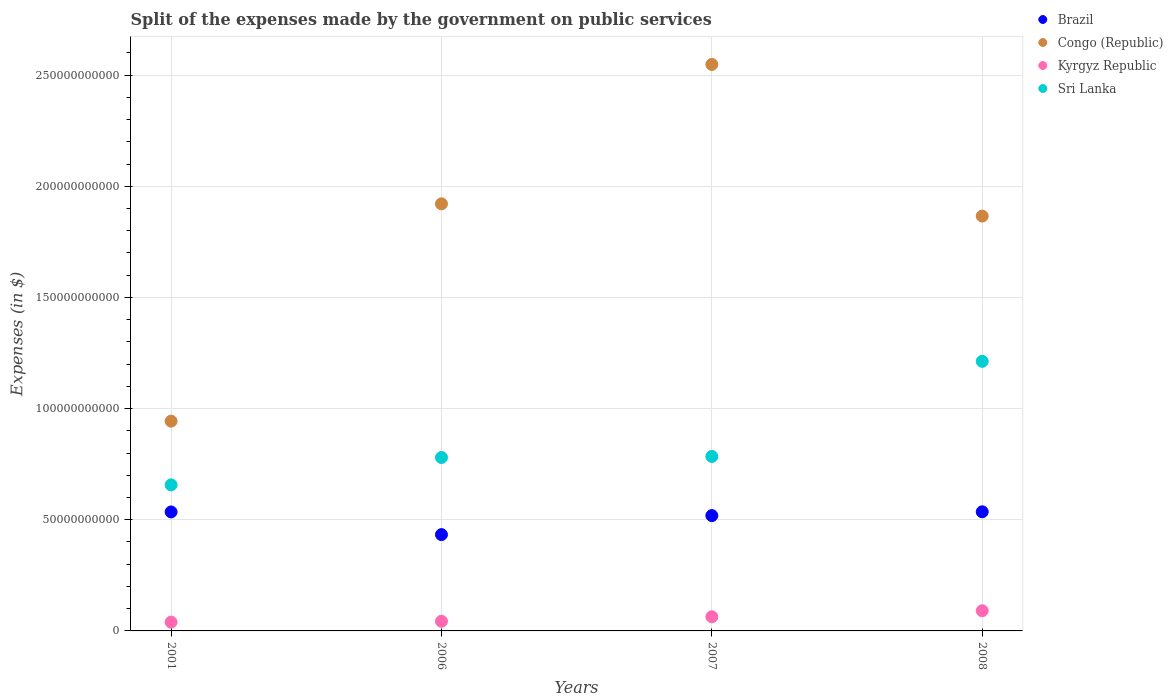How many different coloured dotlines are there?
Offer a very short reply. 4. Is the number of dotlines equal to the number of legend labels?
Your answer should be compact. Yes. What is the expenses made by the government on public services in Kyrgyz Republic in 2006?
Offer a terse response. 4.35e+09. Across all years, what is the maximum expenses made by the government on public services in Congo (Republic)?
Your response must be concise. 2.55e+11. Across all years, what is the minimum expenses made by the government on public services in Brazil?
Provide a short and direct response. 4.33e+1. In which year was the expenses made by the government on public services in Sri Lanka minimum?
Provide a short and direct response. 2001. What is the total expenses made by the government on public services in Brazil in the graph?
Your response must be concise. 2.02e+11. What is the difference between the expenses made by the government on public services in Sri Lanka in 2006 and that in 2007?
Ensure brevity in your answer.  -4.78e+08. What is the difference between the expenses made by the government on public services in Sri Lanka in 2006 and the expenses made by the government on public services in Brazil in 2008?
Keep it short and to the point. 2.44e+1. What is the average expenses made by the government on public services in Congo (Republic) per year?
Ensure brevity in your answer.  1.82e+11. In the year 2006, what is the difference between the expenses made by the government on public services in Congo (Republic) and expenses made by the government on public services in Brazil?
Offer a terse response. 1.49e+11. In how many years, is the expenses made by the government on public services in Sri Lanka greater than 150000000000 $?
Your answer should be compact. 0. What is the ratio of the expenses made by the government on public services in Congo (Republic) in 2001 to that in 2007?
Your answer should be very brief. 0.37. Is the expenses made by the government on public services in Sri Lanka in 2001 less than that in 2006?
Ensure brevity in your answer.  Yes. What is the difference between the highest and the second highest expenses made by the government on public services in Kyrgyz Republic?
Your response must be concise. 2.71e+09. What is the difference between the highest and the lowest expenses made by the government on public services in Kyrgyz Republic?
Provide a short and direct response. 5.13e+09. Is it the case that in every year, the sum of the expenses made by the government on public services in Congo (Republic) and expenses made by the government on public services in Brazil  is greater than the sum of expenses made by the government on public services in Sri Lanka and expenses made by the government on public services in Kyrgyz Republic?
Your answer should be very brief. Yes. Is it the case that in every year, the sum of the expenses made by the government on public services in Sri Lanka and expenses made by the government on public services in Kyrgyz Republic  is greater than the expenses made by the government on public services in Brazil?
Make the answer very short. Yes. Does the expenses made by the government on public services in Brazil monotonically increase over the years?
Provide a succinct answer. No. Is the expenses made by the government on public services in Sri Lanka strictly less than the expenses made by the government on public services in Congo (Republic) over the years?
Provide a short and direct response. Yes. How many dotlines are there?
Provide a short and direct response. 4. How many years are there in the graph?
Your response must be concise. 4. Are the values on the major ticks of Y-axis written in scientific E-notation?
Offer a very short reply. No. Does the graph contain any zero values?
Ensure brevity in your answer.  No. How many legend labels are there?
Give a very brief answer. 4. How are the legend labels stacked?
Give a very brief answer. Vertical. What is the title of the graph?
Make the answer very short. Split of the expenses made by the government on public services. What is the label or title of the X-axis?
Your answer should be very brief. Years. What is the label or title of the Y-axis?
Provide a succinct answer. Expenses (in $). What is the Expenses (in $) in Brazil in 2001?
Offer a very short reply. 5.35e+1. What is the Expenses (in $) of Congo (Republic) in 2001?
Provide a succinct answer. 9.43e+1. What is the Expenses (in $) in Kyrgyz Republic in 2001?
Your response must be concise. 3.95e+09. What is the Expenses (in $) in Sri Lanka in 2001?
Provide a succinct answer. 6.57e+1. What is the Expenses (in $) of Brazil in 2006?
Provide a short and direct response. 4.33e+1. What is the Expenses (in $) in Congo (Republic) in 2006?
Ensure brevity in your answer.  1.92e+11. What is the Expenses (in $) in Kyrgyz Republic in 2006?
Make the answer very short. 4.35e+09. What is the Expenses (in $) in Sri Lanka in 2006?
Provide a succinct answer. 7.80e+1. What is the Expenses (in $) of Brazil in 2007?
Provide a succinct answer. 5.19e+1. What is the Expenses (in $) in Congo (Republic) in 2007?
Give a very brief answer. 2.55e+11. What is the Expenses (in $) of Kyrgyz Republic in 2007?
Ensure brevity in your answer.  6.37e+09. What is the Expenses (in $) of Sri Lanka in 2007?
Give a very brief answer. 7.85e+1. What is the Expenses (in $) of Brazil in 2008?
Provide a short and direct response. 5.36e+1. What is the Expenses (in $) of Congo (Republic) in 2008?
Offer a terse response. 1.87e+11. What is the Expenses (in $) of Kyrgyz Republic in 2008?
Your answer should be compact. 9.08e+09. What is the Expenses (in $) in Sri Lanka in 2008?
Ensure brevity in your answer.  1.21e+11. Across all years, what is the maximum Expenses (in $) of Brazil?
Ensure brevity in your answer.  5.36e+1. Across all years, what is the maximum Expenses (in $) in Congo (Republic)?
Your response must be concise. 2.55e+11. Across all years, what is the maximum Expenses (in $) in Kyrgyz Republic?
Give a very brief answer. 9.08e+09. Across all years, what is the maximum Expenses (in $) of Sri Lanka?
Ensure brevity in your answer.  1.21e+11. Across all years, what is the minimum Expenses (in $) of Brazil?
Keep it short and to the point. 4.33e+1. Across all years, what is the minimum Expenses (in $) in Congo (Republic)?
Offer a very short reply. 9.43e+1. Across all years, what is the minimum Expenses (in $) in Kyrgyz Republic?
Offer a terse response. 3.95e+09. Across all years, what is the minimum Expenses (in $) of Sri Lanka?
Your answer should be compact. 6.57e+1. What is the total Expenses (in $) in Brazil in the graph?
Provide a short and direct response. 2.02e+11. What is the total Expenses (in $) in Congo (Republic) in the graph?
Provide a short and direct response. 7.28e+11. What is the total Expenses (in $) in Kyrgyz Republic in the graph?
Make the answer very short. 2.37e+1. What is the total Expenses (in $) in Sri Lanka in the graph?
Make the answer very short. 3.43e+11. What is the difference between the Expenses (in $) of Brazil in 2001 and that in 2006?
Keep it short and to the point. 1.02e+1. What is the difference between the Expenses (in $) of Congo (Republic) in 2001 and that in 2006?
Make the answer very short. -9.78e+1. What is the difference between the Expenses (in $) in Kyrgyz Republic in 2001 and that in 2006?
Your answer should be very brief. -4.01e+08. What is the difference between the Expenses (in $) of Sri Lanka in 2001 and that in 2006?
Offer a terse response. -1.23e+1. What is the difference between the Expenses (in $) in Brazil in 2001 and that in 2007?
Your answer should be very brief. 1.64e+09. What is the difference between the Expenses (in $) in Congo (Republic) in 2001 and that in 2007?
Provide a succinct answer. -1.60e+11. What is the difference between the Expenses (in $) of Kyrgyz Republic in 2001 and that in 2007?
Provide a succinct answer. -2.42e+09. What is the difference between the Expenses (in $) of Sri Lanka in 2001 and that in 2007?
Give a very brief answer. -1.28e+1. What is the difference between the Expenses (in $) of Brazil in 2001 and that in 2008?
Keep it short and to the point. -6.38e+07. What is the difference between the Expenses (in $) of Congo (Republic) in 2001 and that in 2008?
Provide a short and direct response. -9.22e+1. What is the difference between the Expenses (in $) of Kyrgyz Republic in 2001 and that in 2008?
Make the answer very short. -5.13e+09. What is the difference between the Expenses (in $) of Sri Lanka in 2001 and that in 2008?
Keep it short and to the point. -5.56e+1. What is the difference between the Expenses (in $) in Brazil in 2006 and that in 2007?
Offer a terse response. -8.54e+09. What is the difference between the Expenses (in $) in Congo (Republic) in 2006 and that in 2007?
Your answer should be very brief. -6.27e+1. What is the difference between the Expenses (in $) in Kyrgyz Republic in 2006 and that in 2007?
Ensure brevity in your answer.  -2.02e+09. What is the difference between the Expenses (in $) of Sri Lanka in 2006 and that in 2007?
Your answer should be compact. -4.78e+08. What is the difference between the Expenses (in $) of Brazil in 2006 and that in 2008?
Your answer should be compact. -1.03e+1. What is the difference between the Expenses (in $) in Congo (Republic) in 2006 and that in 2008?
Provide a succinct answer. 5.52e+09. What is the difference between the Expenses (in $) of Kyrgyz Republic in 2006 and that in 2008?
Keep it short and to the point. -4.73e+09. What is the difference between the Expenses (in $) in Sri Lanka in 2006 and that in 2008?
Provide a succinct answer. -4.33e+1. What is the difference between the Expenses (in $) in Brazil in 2007 and that in 2008?
Offer a very short reply. -1.71e+09. What is the difference between the Expenses (in $) of Congo (Republic) in 2007 and that in 2008?
Ensure brevity in your answer.  6.82e+1. What is the difference between the Expenses (in $) in Kyrgyz Republic in 2007 and that in 2008?
Your answer should be compact. -2.71e+09. What is the difference between the Expenses (in $) of Sri Lanka in 2007 and that in 2008?
Offer a terse response. -4.28e+1. What is the difference between the Expenses (in $) of Brazil in 2001 and the Expenses (in $) of Congo (Republic) in 2006?
Ensure brevity in your answer.  -1.39e+11. What is the difference between the Expenses (in $) of Brazil in 2001 and the Expenses (in $) of Kyrgyz Republic in 2006?
Your answer should be compact. 4.92e+1. What is the difference between the Expenses (in $) of Brazil in 2001 and the Expenses (in $) of Sri Lanka in 2006?
Your answer should be very brief. -2.45e+1. What is the difference between the Expenses (in $) in Congo (Republic) in 2001 and the Expenses (in $) in Kyrgyz Republic in 2006?
Ensure brevity in your answer.  9.00e+1. What is the difference between the Expenses (in $) of Congo (Republic) in 2001 and the Expenses (in $) of Sri Lanka in 2006?
Provide a short and direct response. 1.64e+1. What is the difference between the Expenses (in $) of Kyrgyz Republic in 2001 and the Expenses (in $) of Sri Lanka in 2006?
Provide a short and direct response. -7.40e+1. What is the difference between the Expenses (in $) in Brazil in 2001 and the Expenses (in $) in Congo (Republic) in 2007?
Keep it short and to the point. -2.01e+11. What is the difference between the Expenses (in $) in Brazil in 2001 and the Expenses (in $) in Kyrgyz Republic in 2007?
Make the answer very short. 4.71e+1. What is the difference between the Expenses (in $) of Brazil in 2001 and the Expenses (in $) of Sri Lanka in 2007?
Keep it short and to the point. -2.50e+1. What is the difference between the Expenses (in $) in Congo (Republic) in 2001 and the Expenses (in $) in Kyrgyz Republic in 2007?
Offer a terse response. 8.80e+1. What is the difference between the Expenses (in $) of Congo (Republic) in 2001 and the Expenses (in $) of Sri Lanka in 2007?
Your answer should be very brief. 1.59e+1. What is the difference between the Expenses (in $) of Kyrgyz Republic in 2001 and the Expenses (in $) of Sri Lanka in 2007?
Offer a terse response. -7.45e+1. What is the difference between the Expenses (in $) in Brazil in 2001 and the Expenses (in $) in Congo (Republic) in 2008?
Provide a succinct answer. -1.33e+11. What is the difference between the Expenses (in $) of Brazil in 2001 and the Expenses (in $) of Kyrgyz Republic in 2008?
Ensure brevity in your answer.  4.44e+1. What is the difference between the Expenses (in $) of Brazil in 2001 and the Expenses (in $) of Sri Lanka in 2008?
Provide a succinct answer. -6.77e+1. What is the difference between the Expenses (in $) in Congo (Republic) in 2001 and the Expenses (in $) in Kyrgyz Republic in 2008?
Offer a very short reply. 8.53e+1. What is the difference between the Expenses (in $) in Congo (Republic) in 2001 and the Expenses (in $) in Sri Lanka in 2008?
Keep it short and to the point. -2.69e+1. What is the difference between the Expenses (in $) in Kyrgyz Republic in 2001 and the Expenses (in $) in Sri Lanka in 2008?
Your answer should be very brief. -1.17e+11. What is the difference between the Expenses (in $) of Brazil in 2006 and the Expenses (in $) of Congo (Republic) in 2007?
Your response must be concise. -2.11e+11. What is the difference between the Expenses (in $) of Brazil in 2006 and the Expenses (in $) of Kyrgyz Republic in 2007?
Ensure brevity in your answer.  3.70e+1. What is the difference between the Expenses (in $) of Brazil in 2006 and the Expenses (in $) of Sri Lanka in 2007?
Your answer should be compact. -3.51e+1. What is the difference between the Expenses (in $) of Congo (Republic) in 2006 and the Expenses (in $) of Kyrgyz Republic in 2007?
Offer a very short reply. 1.86e+11. What is the difference between the Expenses (in $) of Congo (Republic) in 2006 and the Expenses (in $) of Sri Lanka in 2007?
Ensure brevity in your answer.  1.14e+11. What is the difference between the Expenses (in $) in Kyrgyz Republic in 2006 and the Expenses (in $) in Sri Lanka in 2007?
Your answer should be compact. -7.41e+1. What is the difference between the Expenses (in $) in Brazil in 2006 and the Expenses (in $) in Congo (Republic) in 2008?
Your answer should be very brief. -1.43e+11. What is the difference between the Expenses (in $) of Brazil in 2006 and the Expenses (in $) of Kyrgyz Republic in 2008?
Provide a succinct answer. 3.42e+1. What is the difference between the Expenses (in $) of Brazil in 2006 and the Expenses (in $) of Sri Lanka in 2008?
Ensure brevity in your answer.  -7.79e+1. What is the difference between the Expenses (in $) in Congo (Republic) in 2006 and the Expenses (in $) in Kyrgyz Republic in 2008?
Your response must be concise. 1.83e+11. What is the difference between the Expenses (in $) in Congo (Republic) in 2006 and the Expenses (in $) in Sri Lanka in 2008?
Offer a terse response. 7.08e+1. What is the difference between the Expenses (in $) in Kyrgyz Republic in 2006 and the Expenses (in $) in Sri Lanka in 2008?
Your answer should be compact. -1.17e+11. What is the difference between the Expenses (in $) in Brazil in 2007 and the Expenses (in $) in Congo (Republic) in 2008?
Your response must be concise. -1.35e+11. What is the difference between the Expenses (in $) of Brazil in 2007 and the Expenses (in $) of Kyrgyz Republic in 2008?
Offer a terse response. 4.28e+1. What is the difference between the Expenses (in $) in Brazil in 2007 and the Expenses (in $) in Sri Lanka in 2008?
Your response must be concise. -6.94e+1. What is the difference between the Expenses (in $) of Congo (Republic) in 2007 and the Expenses (in $) of Kyrgyz Republic in 2008?
Offer a very short reply. 2.46e+11. What is the difference between the Expenses (in $) of Congo (Republic) in 2007 and the Expenses (in $) of Sri Lanka in 2008?
Keep it short and to the point. 1.34e+11. What is the difference between the Expenses (in $) of Kyrgyz Republic in 2007 and the Expenses (in $) of Sri Lanka in 2008?
Ensure brevity in your answer.  -1.15e+11. What is the average Expenses (in $) of Brazil per year?
Make the answer very short. 5.06e+1. What is the average Expenses (in $) of Congo (Republic) per year?
Offer a terse response. 1.82e+11. What is the average Expenses (in $) in Kyrgyz Republic per year?
Ensure brevity in your answer.  5.94e+09. What is the average Expenses (in $) of Sri Lanka per year?
Your response must be concise. 8.59e+1. In the year 2001, what is the difference between the Expenses (in $) in Brazil and Expenses (in $) in Congo (Republic)?
Make the answer very short. -4.08e+1. In the year 2001, what is the difference between the Expenses (in $) of Brazil and Expenses (in $) of Kyrgyz Republic?
Your response must be concise. 4.96e+1. In the year 2001, what is the difference between the Expenses (in $) of Brazil and Expenses (in $) of Sri Lanka?
Provide a short and direct response. -1.22e+1. In the year 2001, what is the difference between the Expenses (in $) of Congo (Republic) and Expenses (in $) of Kyrgyz Republic?
Ensure brevity in your answer.  9.04e+1. In the year 2001, what is the difference between the Expenses (in $) in Congo (Republic) and Expenses (in $) in Sri Lanka?
Provide a short and direct response. 2.87e+1. In the year 2001, what is the difference between the Expenses (in $) of Kyrgyz Republic and Expenses (in $) of Sri Lanka?
Your answer should be compact. -6.17e+1. In the year 2006, what is the difference between the Expenses (in $) in Brazil and Expenses (in $) in Congo (Republic)?
Your answer should be compact. -1.49e+11. In the year 2006, what is the difference between the Expenses (in $) of Brazil and Expenses (in $) of Kyrgyz Republic?
Make the answer very short. 3.90e+1. In the year 2006, what is the difference between the Expenses (in $) of Brazil and Expenses (in $) of Sri Lanka?
Your answer should be very brief. -3.47e+1. In the year 2006, what is the difference between the Expenses (in $) in Congo (Republic) and Expenses (in $) in Kyrgyz Republic?
Your answer should be compact. 1.88e+11. In the year 2006, what is the difference between the Expenses (in $) of Congo (Republic) and Expenses (in $) of Sri Lanka?
Your answer should be compact. 1.14e+11. In the year 2006, what is the difference between the Expenses (in $) in Kyrgyz Republic and Expenses (in $) in Sri Lanka?
Your answer should be very brief. -7.36e+1. In the year 2007, what is the difference between the Expenses (in $) in Brazil and Expenses (in $) in Congo (Republic)?
Provide a succinct answer. -2.03e+11. In the year 2007, what is the difference between the Expenses (in $) in Brazil and Expenses (in $) in Kyrgyz Republic?
Keep it short and to the point. 4.55e+1. In the year 2007, what is the difference between the Expenses (in $) of Brazil and Expenses (in $) of Sri Lanka?
Provide a short and direct response. -2.66e+1. In the year 2007, what is the difference between the Expenses (in $) of Congo (Republic) and Expenses (in $) of Kyrgyz Republic?
Your answer should be compact. 2.48e+11. In the year 2007, what is the difference between the Expenses (in $) of Congo (Republic) and Expenses (in $) of Sri Lanka?
Make the answer very short. 1.76e+11. In the year 2007, what is the difference between the Expenses (in $) in Kyrgyz Republic and Expenses (in $) in Sri Lanka?
Make the answer very short. -7.21e+1. In the year 2008, what is the difference between the Expenses (in $) of Brazil and Expenses (in $) of Congo (Republic)?
Offer a terse response. -1.33e+11. In the year 2008, what is the difference between the Expenses (in $) of Brazil and Expenses (in $) of Kyrgyz Republic?
Make the answer very short. 4.45e+1. In the year 2008, what is the difference between the Expenses (in $) in Brazil and Expenses (in $) in Sri Lanka?
Offer a very short reply. -6.77e+1. In the year 2008, what is the difference between the Expenses (in $) in Congo (Republic) and Expenses (in $) in Kyrgyz Republic?
Your response must be concise. 1.78e+11. In the year 2008, what is the difference between the Expenses (in $) in Congo (Republic) and Expenses (in $) in Sri Lanka?
Your response must be concise. 6.53e+1. In the year 2008, what is the difference between the Expenses (in $) of Kyrgyz Republic and Expenses (in $) of Sri Lanka?
Make the answer very short. -1.12e+11. What is the ratio of the Expenses (in $) in Brazil in 2001 to that in 2006?
Ensure brevity in your answer.  1.24. What is the ratio of the Expenses (in $) of Congo (Republic) in 2001 to that in 2006?
Offer a very short reply. 0.49. What is the ratio of the Expenses (in $) in Kyrgyz Republic in 2001 to that in 2006?
Your answer should be very brief. 0.91. What is the ratio of the Expenses (in $) of Sri Lanka in 2001 to that in 2006?
Offer a terse response. 0.84. What is the ratio of the Expenses (in $) of Brazil in 2001 to that in 2007?
Provide a short and direct response. 1.03. What is the ratio of the Expenses (in $) in Congo (Republic) in 2001 to that in 2007?
Provide a short and direct response. 0.37. What is the ratio of the Expenses (in $) in Kyrgyz Republic in 2001 to that in 2007?
Provide a succinct answer. 0.62. What is the ratio of the Expenses (in $) of Sri Lanka in 2001 to that in 2007?
Keep it short and to the point. 0.84. What is the ratio of the Expenses (in $) of Congo (Republic) in 2001 to that in 2008?
Your answer should be very brief. 0.51. What is the ratio of the Expenses (in $) of Kyrgyz Republic in 2001 to that in 2008?
Offer a very short reply. 0.43. What is the ratio of the Expenses (in $) in Sri Lanka in 2001 to that in 2008?
Offer a very short reply. 0.54. What is the ratio of the Expenses (in $) in Brazil in 2006 to that in 2007?
Your response must be concise. 0.84. What is the ratio of the Expenses (in $) of Congo (Republic) in 2006 to that in 2007?
Make the answer very short. 0.75. What is the ratio of the Expenses (in $) of Kyrgyz Republic in 2006 to that in 2007?
Your answer should be compact. 0.68. What is the ratio of the Expenses (in $) in Brazil in 2006 to that in 2008?
Your answer should be compact. 0.81. What is the ratio of the Expenses (in $) of Congo (Republic) in 2006 to that in 2008?
Keep it short and to the point. 1.03. What is the ratio of the Expenses (in $) of Kyrgyz Republic in 2006 to that in 2008?
Your response must be concise. 0.48. What is the ratio of the Expenses (in $) in Sri Lanka in 2006 to that in 2008?
Offer a terse response. 0.64. What is the ratio of the Expenses (in $) in Brazil in 2007 to that in 2008?
Offer a terse response. 0.97. What is the ratio of the Expenses (in $) of Congo (Republic) in 2007 to that in 2008?
Your answer should be very brief. 1.37. What is the ratio of the Expenses (in $) of Kyrgyz Republic in 2007 to that in 2008?
Provide a succinct answer. 0.7. What is the ratio of the Expenses (in $) of Sri Lanka in 2007 to that in 2008?
Keep it short and to the point. 0.65. What is the difference between the highest and the second highest Expenses (in $) in Brazil?
Offer a terse response. 6.38e+07. What is the difference between the highest and the second highest Expenses (in $) in Congo (Republic)?
Your answer should be compact. 6.27e+1. What is the difference between the highest and the second highest Expenses (in $) in Kyrgyz Republic?
Your answer should be compact. 2.71e+09. What is the difference between the highest and the second highest Expenses (in $) in Sri Lanka?
Provide a succinct answer. 4.28e+1. What is the difference between the highest and the lowest Expenses (in $) in Brazil?
Keep it short and to the point. 1.03e+1. What is the difference between the highest and the lowest Expenses (in $) of Congo (Republic)?
Give a very brief answer. 1.60e+11. What is the difference between the highest and the lowest Expenses (in $) in Kyrgyz Republic?
Your answer should be compact. 5.13e+09. What is the difference between the highest and the lowest Expenses (in $) of Sri Lanka?
Offer a very short reply. 5.56e+1. 